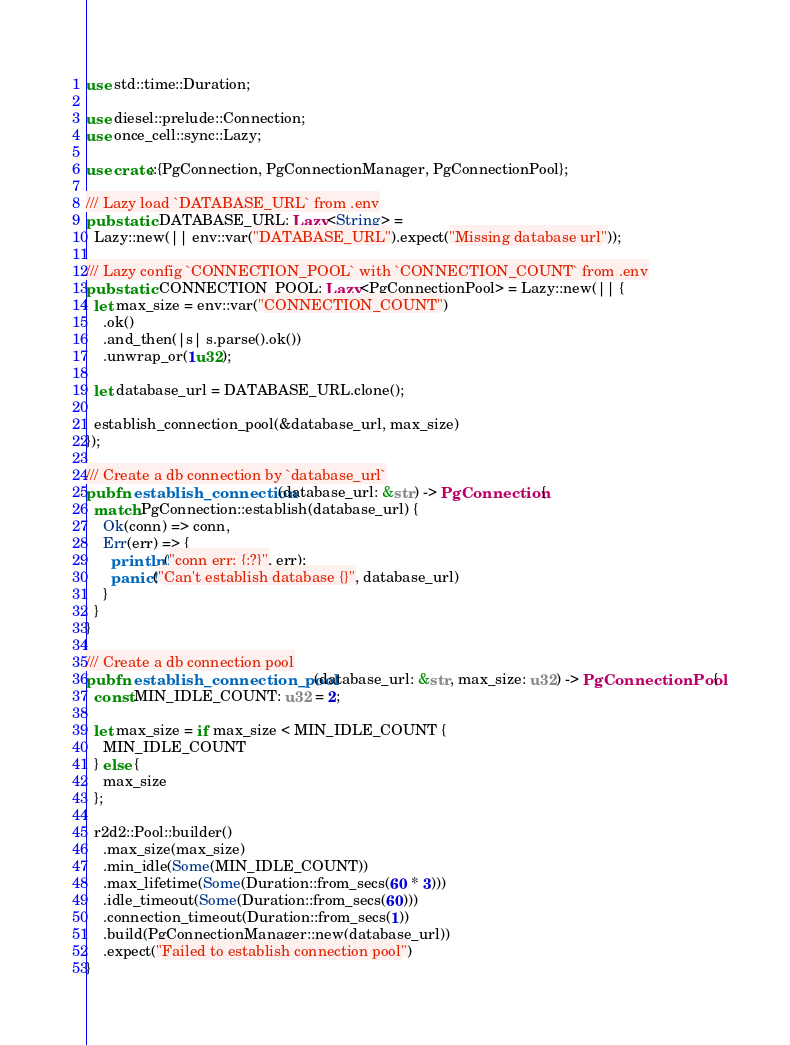Convert code to text. <code><loc_0><loc_0><loc_500><loc_500><_Rust_>use std::time::Duration;

use diesel::prelude::Connection;
use once_cell::sync::Lazy;

use crate::{PgConnection, PgConnectionManager, PgConnectionPool};

/// Lazy load `DATABASE_URL` from .env
pub static DATABASE_URL: Lazy<String> =
  Lazy::new(|| env::var("DATABASE_URL").expect("Missing database url"));

/// Lazy config `CONNECTION_POOL` with `CONNECTION_COUNT` from .env
pub static CONNECTION_POOL: Lazy<PgConnectionPool> = Lazy::new(|| {
  let max_size = env::var("CONNECTION_COUNT")
    .ok()
    .and_then(|s| s.parse().ok())
    .unwrap_or(1u32);

  let database_url = DATABASE_URL.clone();

  establish_connection_pool(&database_url, max_size)
});

/// Create a db connection by `database_url`
pub fn establish_connection(database_url: &str) -> PgConnection {
  match PgConnection::establish(database_url) {
    Ok(conn) => conn,
    Err(err) => {
      println!("conn err: {:?}", err);
      panic!("Can't establish database {}", database_url)
    }
  }
}

/// Create a db connection pool
pub fn establish_connection_pool(database_url: &str, max_size: u32) -> PgConnectionPool {
  const MIN_IDLE_COUNT: u32 = 2;

  let max_size = if max_size < MIN_IDLE_COUNT {
    MIN_IDLE_COUNT
  } else {
    max_size
  };

  r2d2::Pool::builder()
    .max_size(max_size)
    .min_idle(Some(MIN_IDLE_COUNT))
    .max_lifetime(Some(Duration::from_secs(60 * 3)))
    .idle_timeout(Some(Duration::from_secs(60)))
    .connection_timeout(Duration::from_secs(1))
    .build(PgConnectionManager::new(database_url))
    .expect("Failed to establish connection pool")
}
</code> 